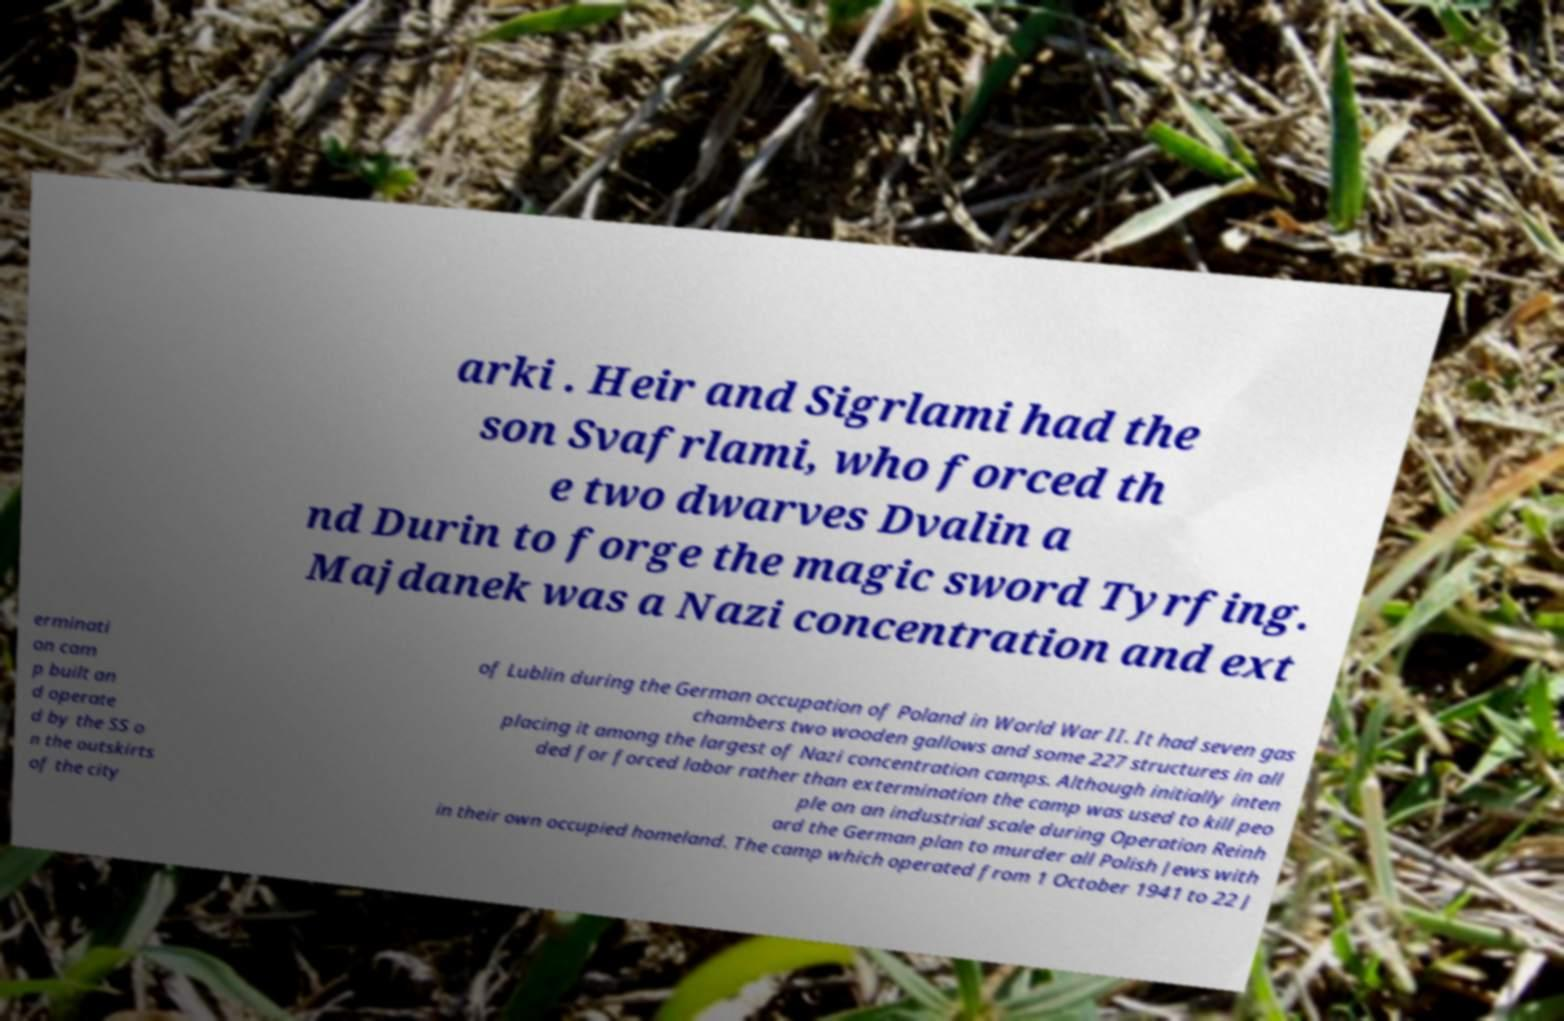There's text embedded in this image that I need extracted. Can you transcribe it verbatim? arki . Heir and Sigrlami had the son Svafrlami, who forced th e two dwarves Dvalin a nd Durin to forge the magic sword Tyrfing. Majdanek was a Nazi concentration and ext erminati on cam p built an d operate d by the SS o n the outskirts of the city of Lublin during the German occupation of Poland in World War II. It had seven gas chambers two wooden gallows and some 227 structures in all placing it among the largest of Nazi concentration camps. Although initially inten ded for forced labor rather than extermination the camp was used to kill peo ple on an industrial scale during Operation Reinh ard the German plan to murder all Polish Jews with in their own occupied homeland. The camp which operated from 1 October 1941 to 22 J 